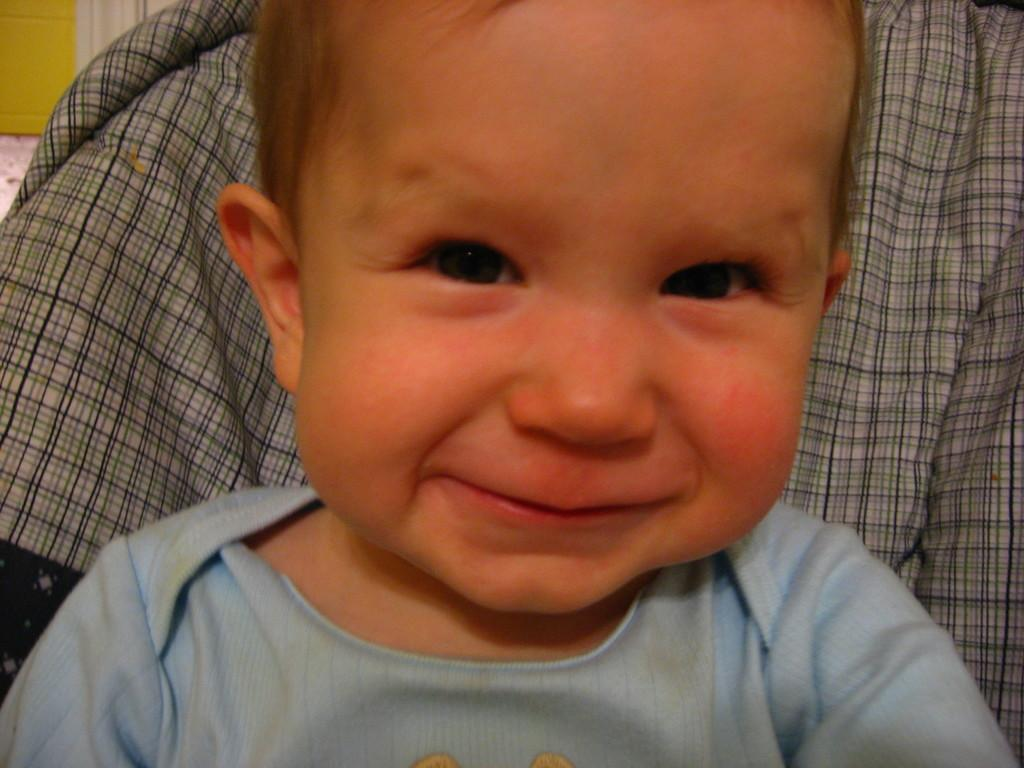What is the main subject of the image? There is a kid in the image. What is the kid wearing? The kid is wearing a blue T-shirt. What can be seen in the background of the image? There is a cloth in the background of the image. What color is the wall on the left side of the image? There is a yellow wall on the left side of the image. Can you see any grass growing on the yellow wall in the image? There is no grass visible on the yellow wall in the image. 